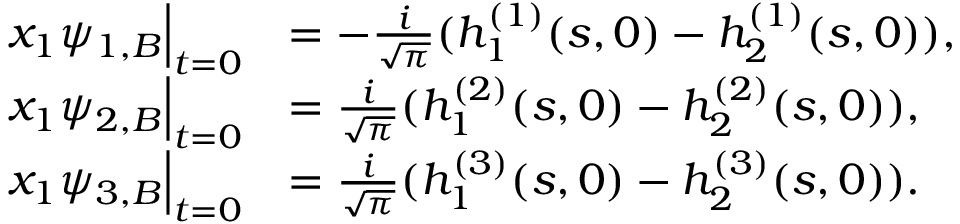Convert formula to latex. <formula><loc_0><loc_0><loc_500><loc_500>\begin{array} { r l } { x _ { 1 } \psi _ { 1 , B } \Big | _ { t = 0 } } & { = - \frac { i } { \sqrt { \pi } } ( h _ { 1 } ^ { ( 1 ) } ( s , 0 ) - h _ { 2 } ^ { ( 1 ) } ( s , 0 ) ) , } \\ { x _ { 1 } \psi _ { 2 , B } \Big | _ { t = 0 } } & { = \frac { i } { \sqrt { \pi } } ( h _ { 1 } ^ { ( 2 ) } ( s , 0 ) - h _ { 2 } ^ { ( 2 ) } ( s , 0 ) ) , } \\ { x _ { 1 } \psi _ { 3 , B } \Big | _ { t = 0 } } & { = \frac { i } { \sqrt { \pi } } ( h _ { 1 } ^ { ( 3 ) } ( s , 0 ) - h _ { 2 } ^ { ( 3 ) } ( s , 0 ) ) . } \end{array}</formula> 